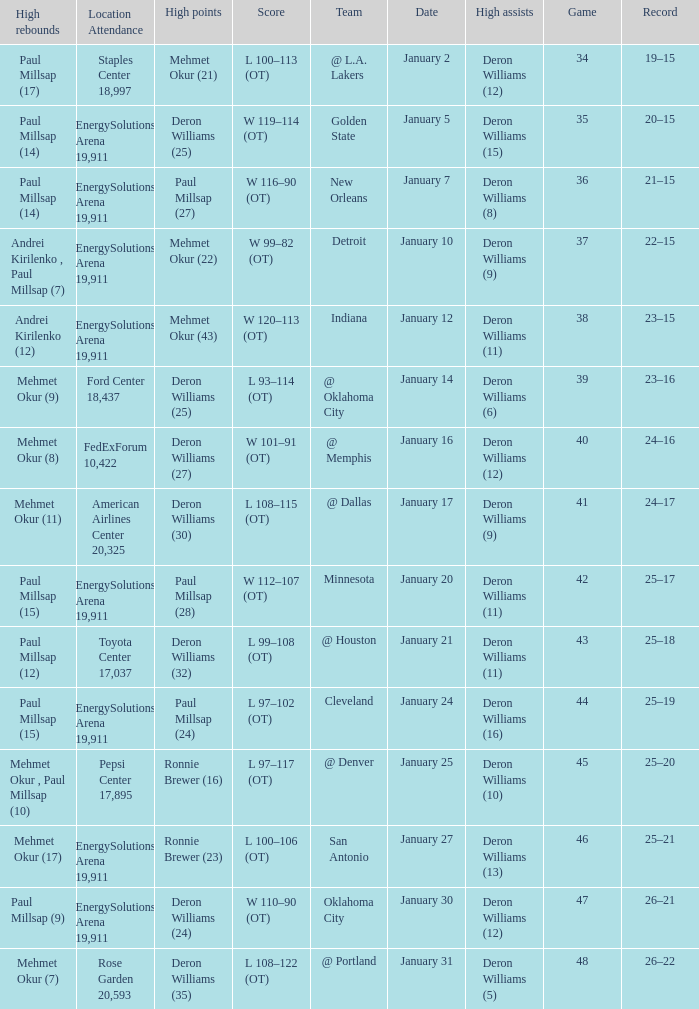Who had the high rebounds on January 24? Paul Millsap (15). 